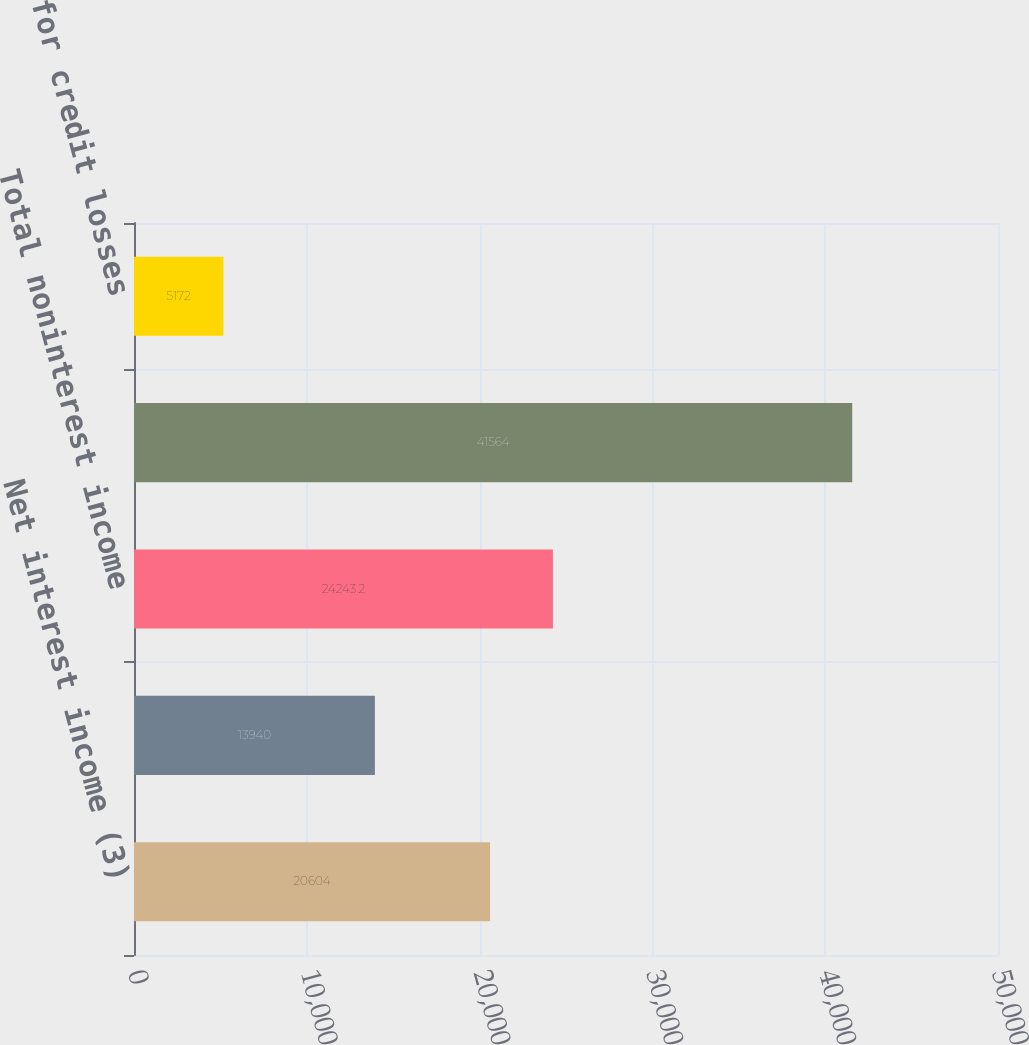<chart> <loc_0><loc_0><loc_500><loc_500><bar_chart><fcel>Net interest income (3)<fcel>Card income<fcel>Total noninterest income<fcel>Total revenue net of interest<fcel>Provision for credit losses<nl><fcel>20604<fcel>13940<fcel>24243.2<fcel>41564<fcel>5172<nl></chart> 